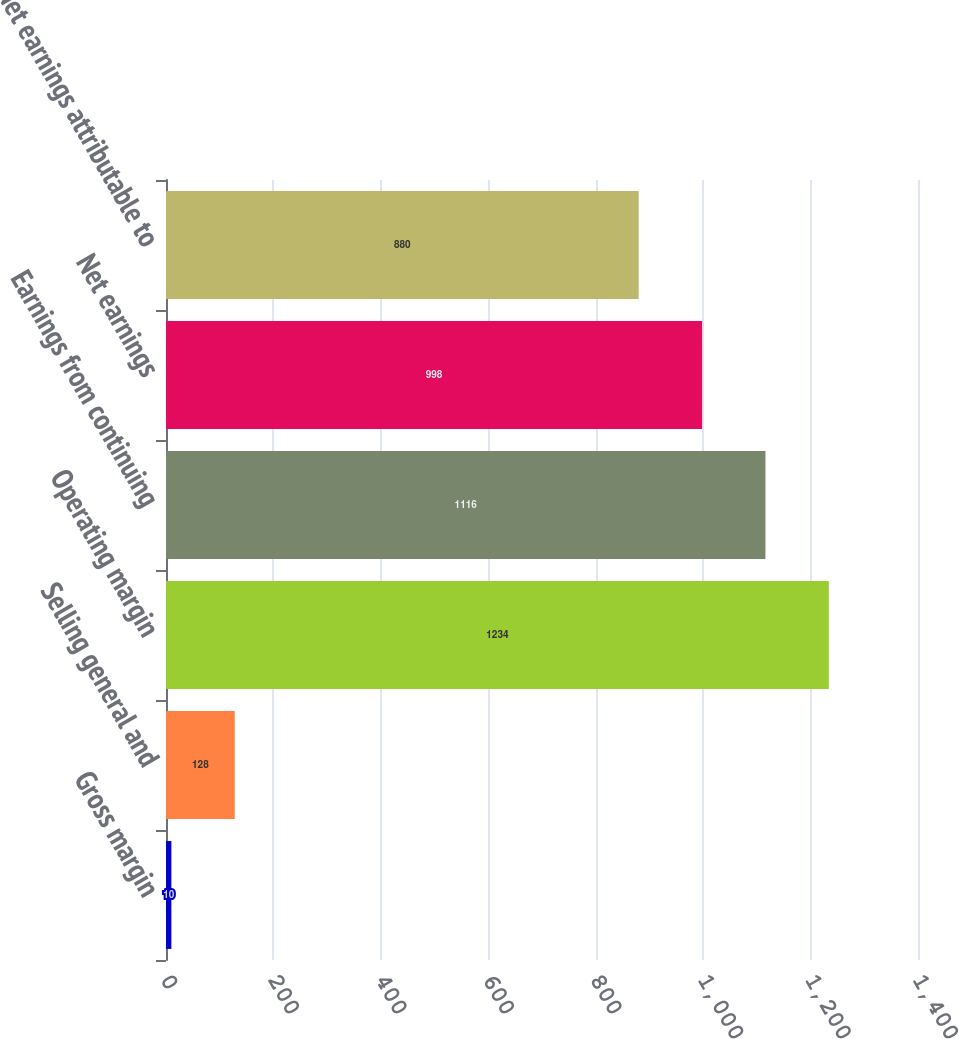Convert chart to OTSL. <chart><loc_0><loc_0><loc_500><loc_500><bar_chart><fcel>Gross margin<fcel>Selling general and<fcel>Operating margin<fcel>Earnings from continuing<fcel>Net earnings<fcel>Net earnings attributable to<nl><fcel>10<fcel>128<fcel>1234<fcel>1116<fcel>998<fcel>880<nl></chart> 